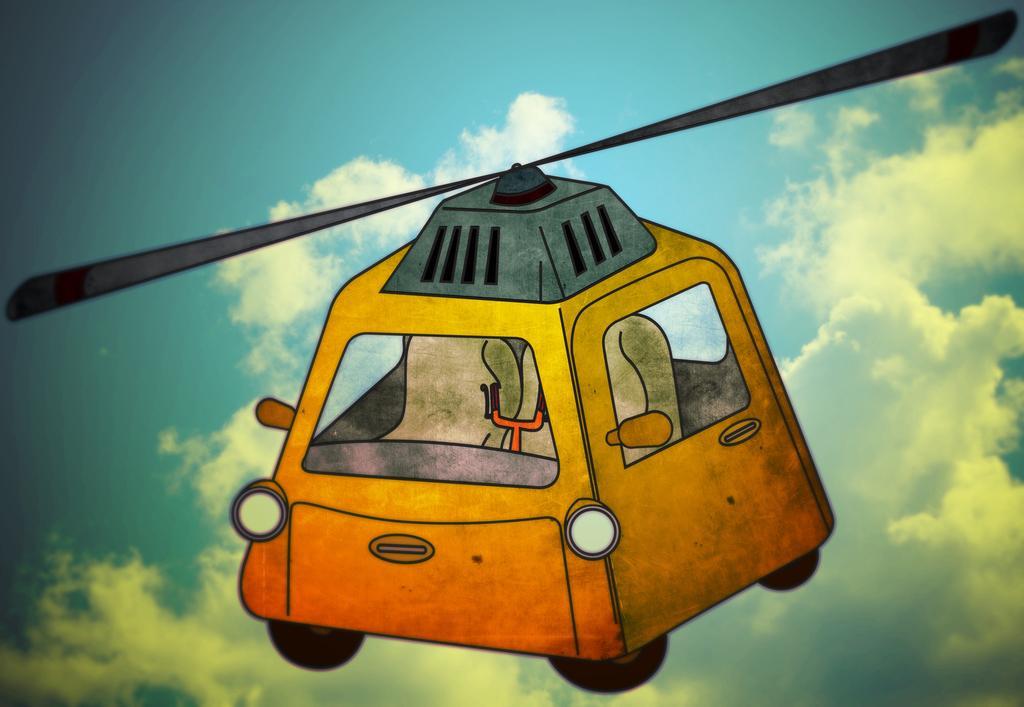Could you give a brief overview of what you see in this image? In this image I can see a depiction of a vehicle. In the background, I can see the clouds in the sky. 